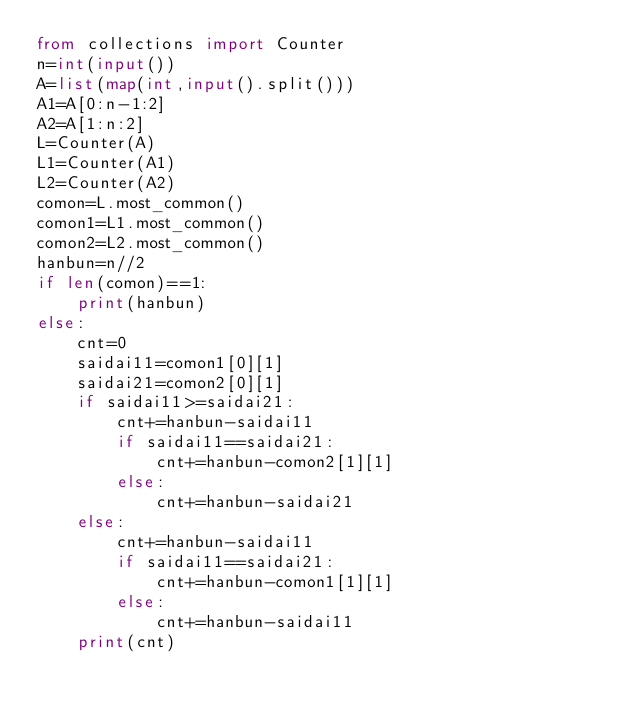Convert code to text. <code><loc_0><loc_0><loc_500><loc_500><_Python_>from collections import Counter
n=int(input())
A=list(map(int,input().split()))
A1=A[0:n-1:2]
A2=A[1:n:2]
L=Counter(A)
L1=Counter(A1)
L2=Counter(A2)
comon=L.most_common()
comon1=L1.most_common()
comon2=L2.most_common()
hanbun=n//2
if len(comon)==1:
    print(hanbun)
else:
    cnt=0
    saidai11=comon1[0][1]
    saidai21=comon2[0][1]
    if saidai11>=saidai21:
        cnt+=hanbun-saidai11
        if saidai11==saidai21:
            cnt+=hanbun-comon2[1][1]
        else:
            cnt+=hanbun-saidai21
    else:
        cnt+=hanbun-saidai11
        if saidai11==saidai21:
            cnt+=hanbun-comon1[1][1]
        else:
            cnt+=hanbun-saidai11
    print(cnt)
    </code> 